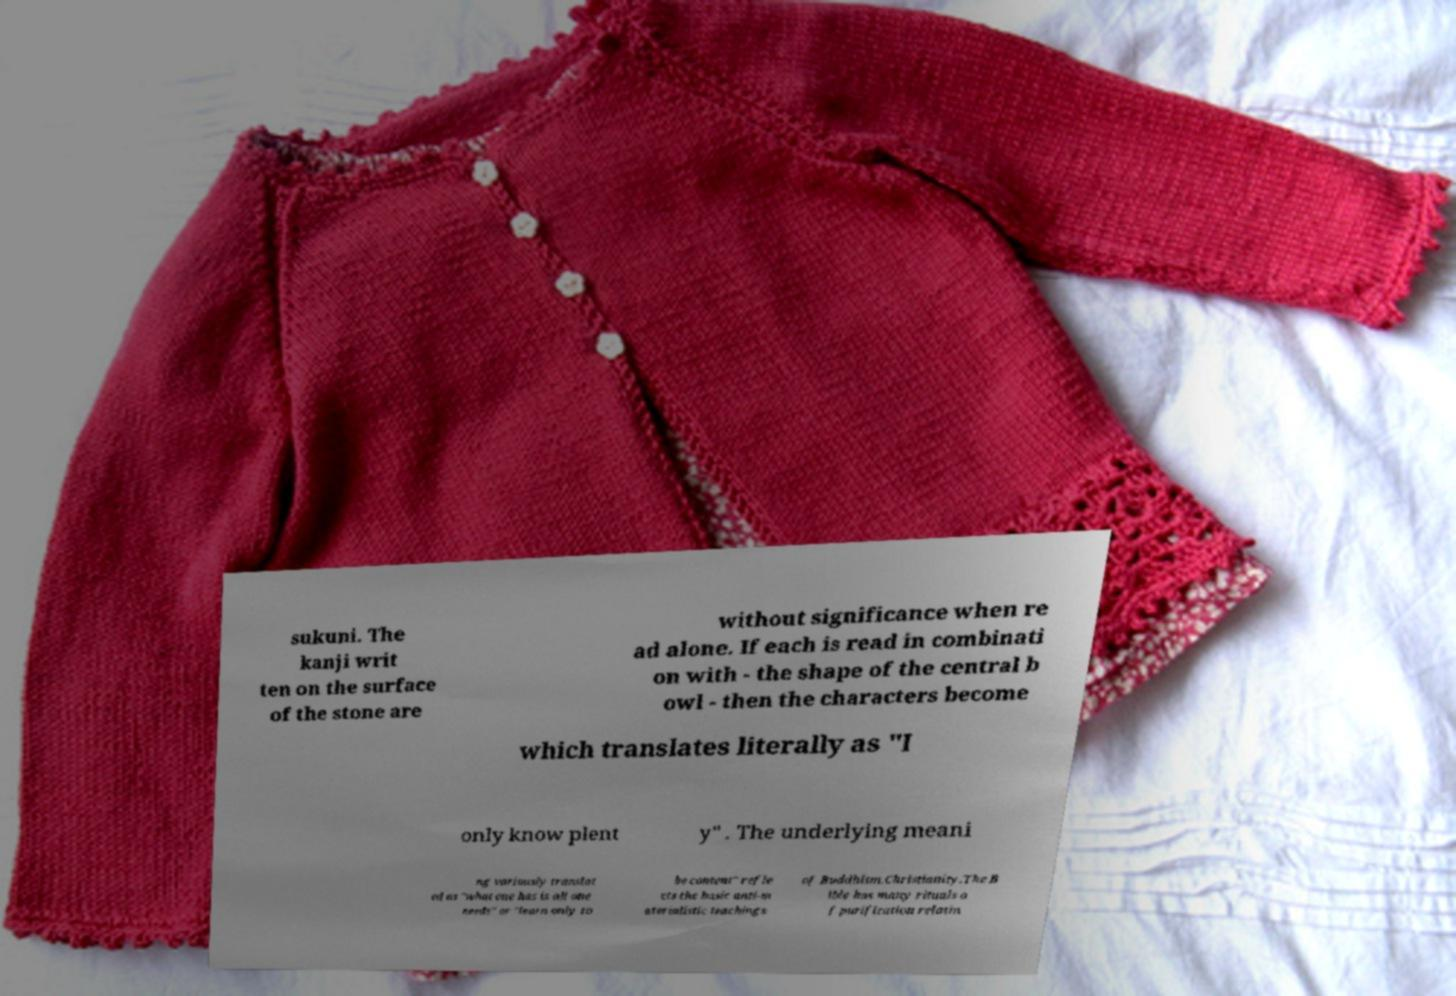What messages or text are displayed in this image? I need them in a readable, typed format. sukuni. The kanji writ ten on the surface of the stone are without significance when re ad alone. If each is read in combinati on with - the shape of the central b owl - then the characters become which translates literally as "I only know plent y" . The underlying meani ng variously translat ed as "what one has is all one needs" or "learn only to be content" refle cts the basic anti-m aterialistic teachings of Buddhism.Christianity.The B ible has many rituals o f purification relatin 